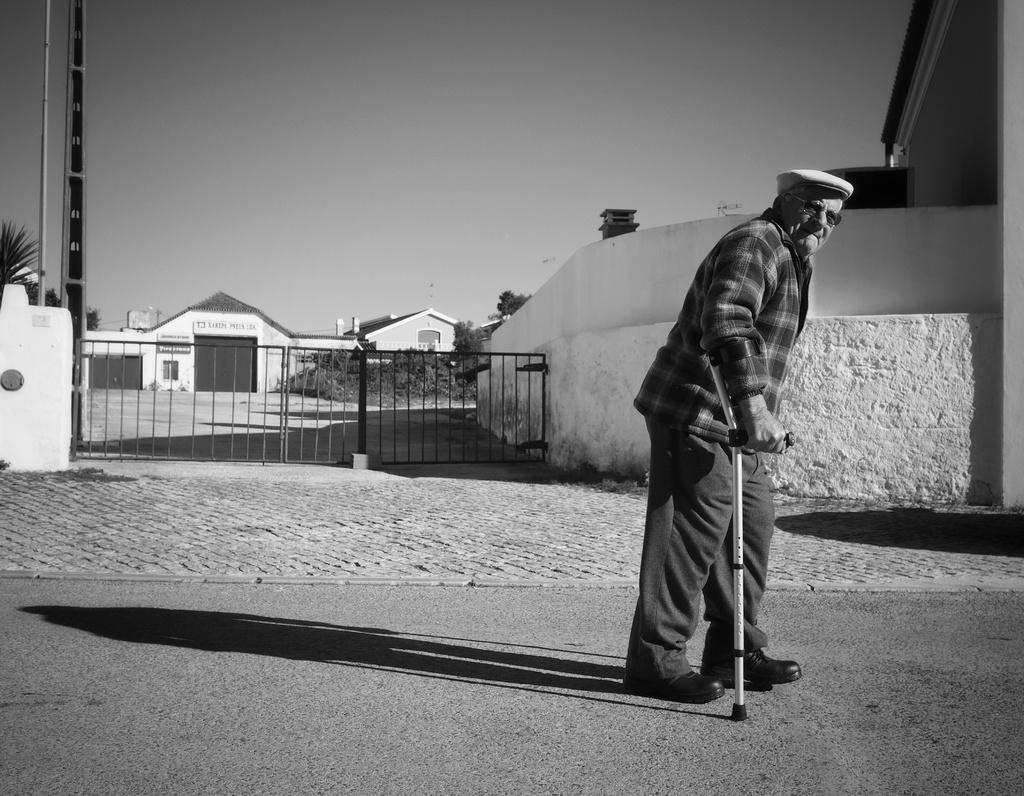What is the main subject of the image? The main subject of the image is a man. Can you describe the man's attire? The man is wearing clothes, shoes, spectacles, and a cap. What objects can be seen in the image besides the man? There is a stick, a road, a fence, a building, a pole, and trees visible in the image. What part of the natural environment is visible in the image? The sky is visible in the image. How does the man show respect to the trees in the image? The image does not depict any actions or emotions, so it cannot be determined how the man shows respect to the trees. What is the man's level of anger in the image? The image does not depict any emotions, so it cannot be determined how angry the man is. 